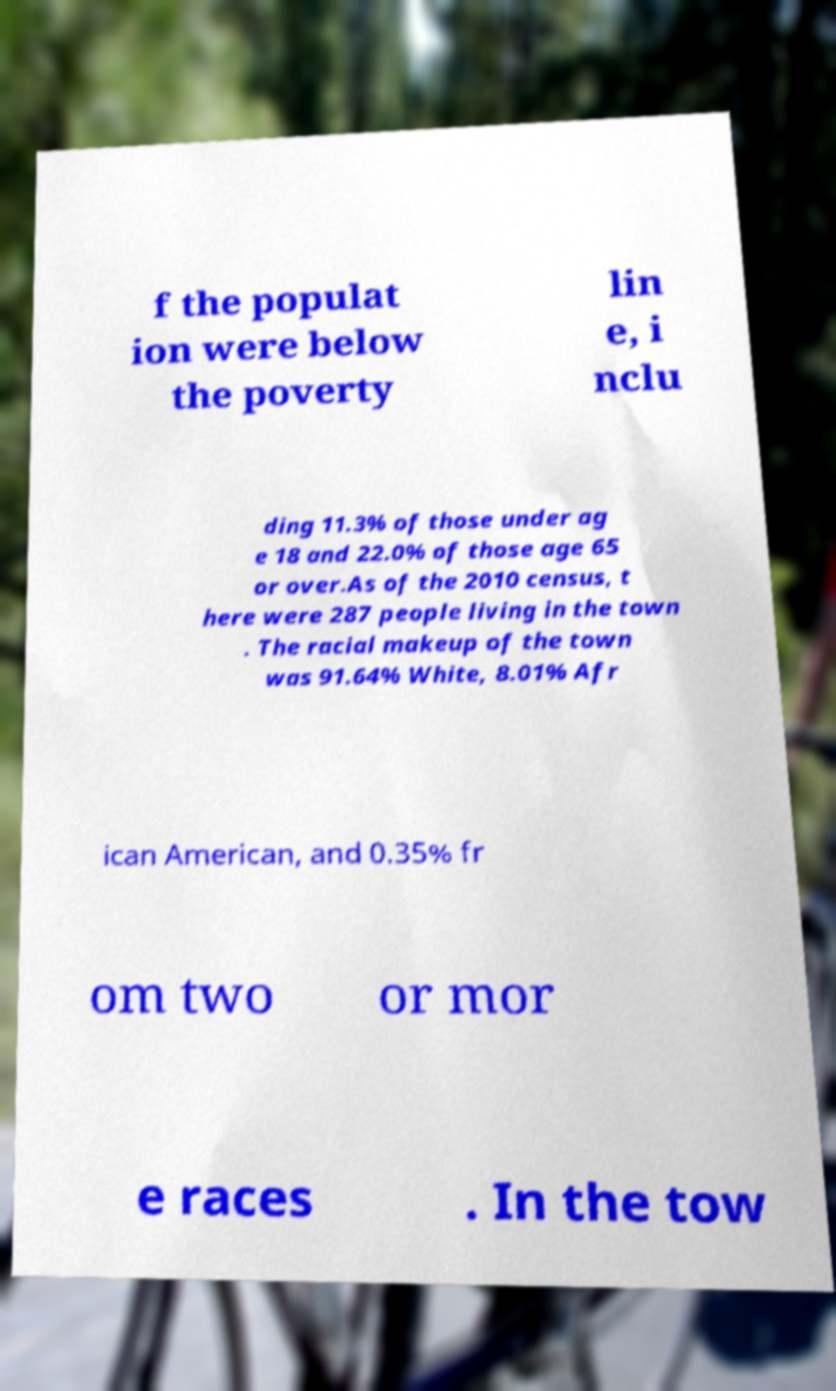Could you extract and type out the text from this image? f the populat ion were below the poverty lin e, i nclu ding 11.3% of those under ag e 18 and 22.0% of those age 65 or over.As of the 2010 census, t here were 287 people living in the town . The racial makeup of the town was 91.64% White, 8.01% Afr ican American, and 0.35% fr om two or mor e races . In the tow 